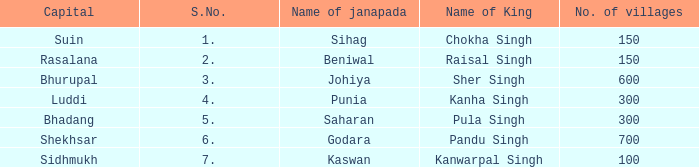Help me parse the entirety of this table. {'header': ['Capital', 'S.No.', 'Name of janapada', 'Name of King', 'No. of villages'], 'rows': [['Suin', '1.', 'Sihag', 'Chokha Singh', '150'], ['Rasalana', '2.', 'Beniwal', 'Raisal Singh', '150'], ['Bhurupal', '3.', 'Johiya', 'Sher Singh', '600'], ['Luddi', '4.', 'Punia', 'Kanha Singh', '300'], ['Bhadang', '5.', 'Saharan', 'Pula Singh', '300'], ['Shekhsar', '6.', 'Godara', 'Pandu Singh', '700'], ['Sidhmukh', '7.', 'Kaswan', 'Kanwarpal Singh', '100']]} What king has an S. number over 1 and a number of villages of 600? Sher Singh. 